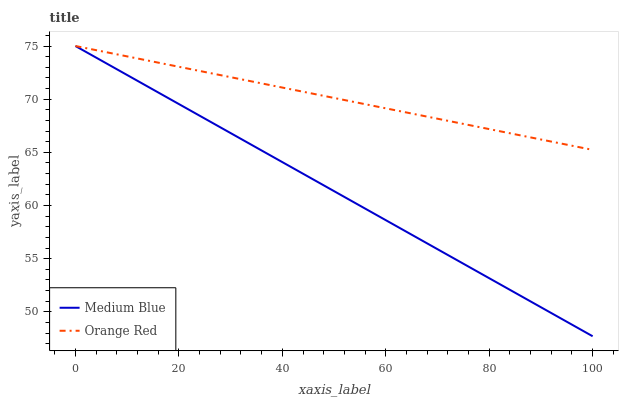Does Medium Blue have the minimum area under the curve?
Answer yes or no. Yes. Does Orange Red have the maximum area under the curve?
Answer yes or no. Yes. Does Orange Red have the minimum area under the curve?
Answer yes or no. No. Is Medium Blue the smoothest?
Answer yes or no. Yes. Is Orange Red the roughest?
Answer yes or no. Yes. Is Orange Red the smoothest?
Answer yes or no. No. Does Medium Blue have the lowest value?
Answer yes or no. Yes. Does Orange Red have the lowest value?
Answer yes or no. No. Does Orange Red have the highest value?
Answer yes or no. Yes. Does Orange Red intersect Medium Blue?
Answer yes or no. Yes. Is Orange Red less than Medium Blue?
Answer yes or no. No. Is Orange Red greater than Medium Blue?
Answer yes or no. No. 